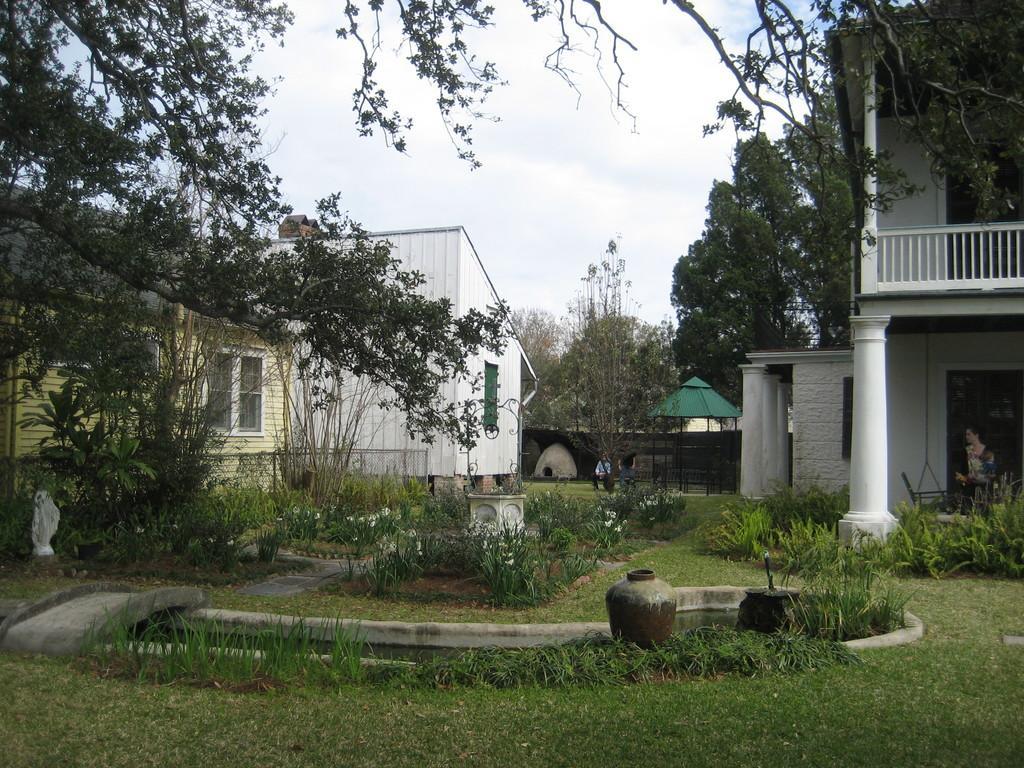Can you describe this image briefly? There are plants, a pot and a grassy land present at the bottom of this image. We can see buildings and trees in the middle of this image and the sky is in the background. 